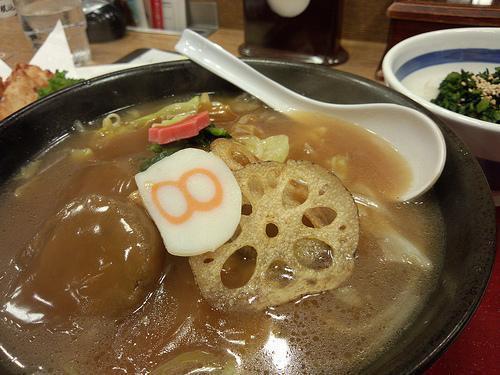How many bowls on the table?
Give a very brief answer. 2. 